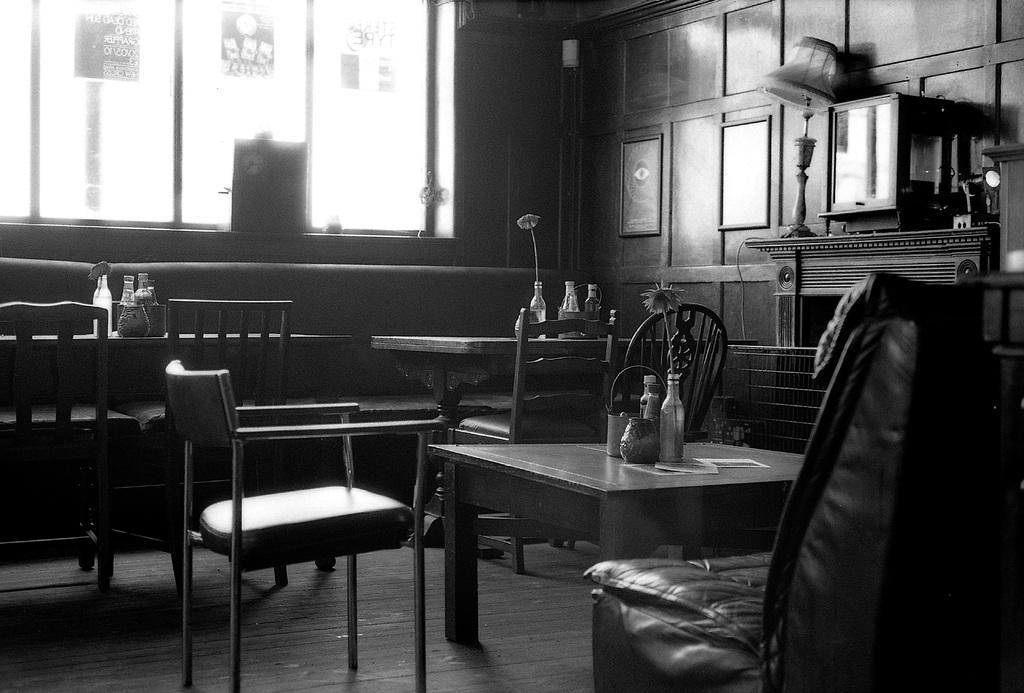In one or two sentences, can you explain what this image depicts? In this picture I can see some chairs, tables, on the table some objects are placed. 